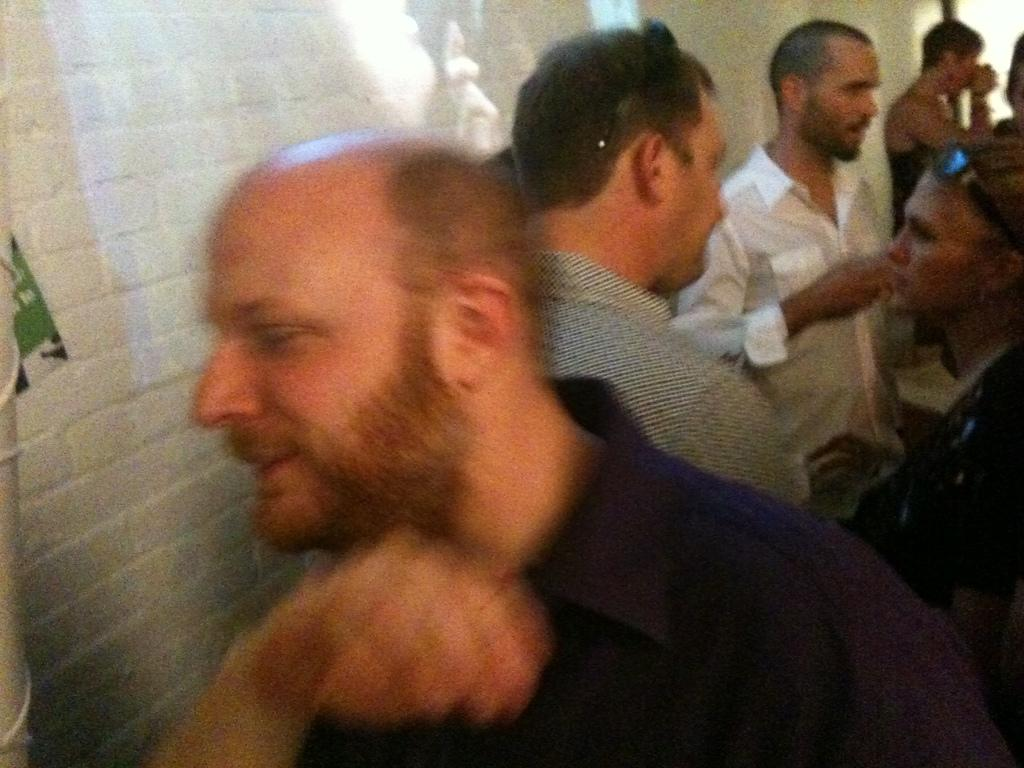How many people are present in the image? There are many people in the image. Can you identify any specific accessories worn by some of the people? Yes, two persons are wearing goggles on their heads. What is located on the left side of the image? There is a wall on the left side of the image. How many snails can be seen crawling on the wall in the image? There are no snails present in the image; the wall is clear of any snails. 